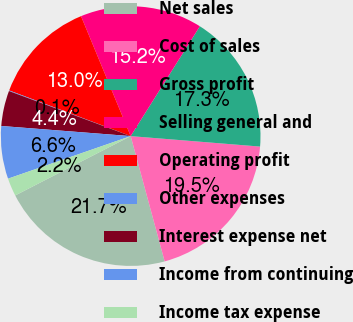Convert chart to OTSL. <chart><loc_0><loc_0><loc_500><loc_500><pie_chart><fcel>Net sales<fcel>Cost of sales<fcel>Gross profit<fcel>Selling general and<fcel>Operating profit<fcel>Other expenses<fcel>Interest expense net<fcel>Income from continuing<fcel>Income tax expense<nl><fcel>21.66%<fcel>19.5%<fcel>17.34%<fcel>15.19%<fcel>13.03%<fcel>0.08%<fcel>4.4%<fcel>6.56%<fcel>2.24%<nl></chart> 